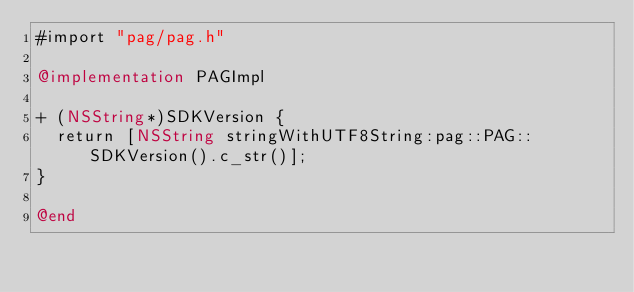Convert code to text. <code><loc_0><loc_0><loc_500><loc_500><_ObjectiveC_>#import "pag/pag.h"

@implementation PAGImpl

+ (NSString*)SDKVersion {
  return [NSString stringWithUTF8String:pag::PAG::SDKVersion().c_str()];
}

@end
</code> 